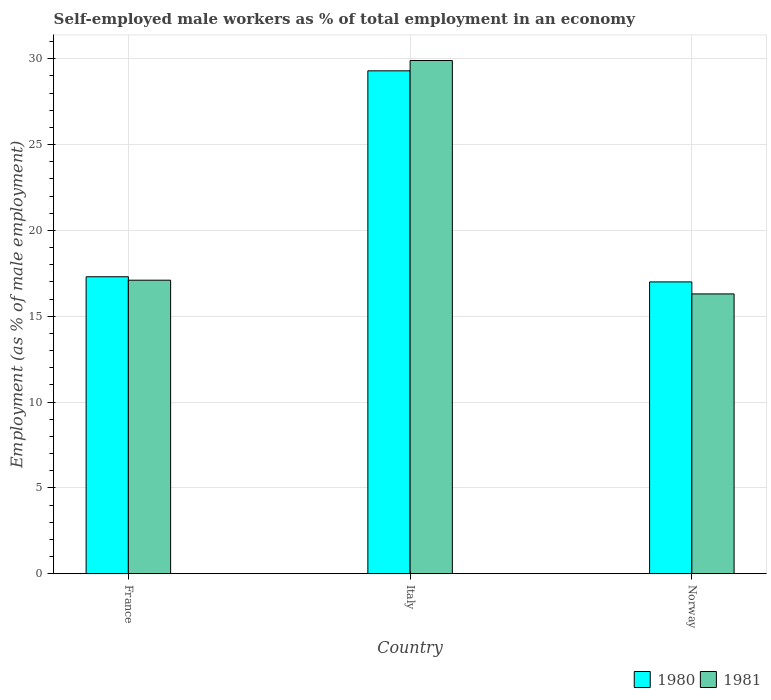How many different coloured bars are there?
Provide a short and direct response. 2. Are the number of bars per tick equal to the number of legend labels?
Your answer should be very brief. Yes. Are the number of bars on each tick of the X-axis equal?
Provide a short and direct response. Yes. How many bars are there on the 1st tick from the left?
Offer a terse response. 2. What is the label of the 3rd group of bars from the left?
Offer a terse response. Norway. In how many cases, is the number of bars for a given country not equal to the number of legend labels?
Give a very brief answer. 0. What is the percentage of self-employed male workers in 1981 in Italy?
Give a very brief answer. 29.9. Across all countries, what is the maximum percentage of self-employed male workers in 1981?
Keep it short and to the point. 29.9. Across all countries, what is the minimum percentage of self-employed male workers in 1981?
Give a very brief answer. 16.3. In which country was the percentage of self-employed male workers in 1981 minimum?
Give a very brief answer. Norway. What is the total percentage of self-employed male workers in 1981 in the graph?
Ensure brevity in your answer.  63.3. What is the difference between the percentage of self-employed male workers in 1981 in France and that in Italy?
Give a very brief answer. -12.8. What is the difference between the percentage of self-employed male workers in 1981 in France and the percentage of self-employed male workers in 1980 in Norway?
Keep it short and to the point. 0.1. What is the average percentage of self-employed male workers in 1980 per country?
Your answer should be compact. 21.2. What is the difference between the percentage of self-employed male workers of/in 1981 and percentage of self-employed male workers of/in 1980 in Italy?
Your answer should be very brief. 0.6. What is the ratio of the percentage of self-employed male workers in 1981 in Italy to that in Norway?
Provide a short and direct response. 1.83. Is the percentage of self-employed male workers in 1980 in France less than that in Norway?
Ensure brevity in your answer.  No. What is the difference between the highest and the second highest percentage of self-employed male workers in 1980?
Ensure brevity in your answer.  -12. What is the difference between the highest and the lowest percentage of self-employed male workers in 1980?
Keep it short and to the point. 12.3. In how many countries, is the percentage of self-employed male workers in 1981 greater than the average percentage of self-employed male workers in 1981 taken over all countries?
Your answer should be very brief. 1. Is the sum of the percentage of self-employed male workers in 1980 in Italy and Norway greater than the maximum percentage of self-employed male workers in 1981 across all countries?
Keep it short and to the point. Yes. What does the 2nd bar from the left in Norway represents?
Offer a very short reply. 1981. What does the 1st bar from the right in Norway represents?
Provide a succinct answer. 1981. How many bars are there?
Provide a succinct answer. 6. Are all the bars in the graph horizontal?
Keep it short and to the point. No. How many countries are there in the graph?
Provide a short and direct response. 3. What is the difference between two consecutive major ticks on the Y-axis?
Provide a short and direct response. 5. Are the values on the major ticks of Y-axis written in scientific E-notation?
Keep it short and to the point. No. Does the graph contain any zero values?
Your answer should be very brief. No. Does the graph contain grids?
Provide a short and direct response. Yes. Where does the legend appear in the graph?
Make the answer very short. Bottom right. What is the title of the graph?
Provide a short and direct response. Self-employed male workers as % of total employment in an economy. What is the label or title of the Y-axis?
Provide a succinct answer. Employment (as % of male employment). What is the Employment (as % of male employment) in 1980 in France?
Your answer should be compact. 17.3. What is the Employment (as % of male employment) in 1981 in France?
Offer a terse response. 17.1. What is the Employment (as % of male employment) of 1980 in Italy?
Ensure brevity in your answer.  29.3. What is the Employment (as % of male employment) of 1981 in Italy?
Offer a terse response. 29.9. What is the Employment (as % of male employment) in 1980 in Norway?
Your response must be concise. 17. What is the Employment (as % of male employment) in 1981 in Norway?
Your answer should be compact. 16.3. Across all countries, what is the maximum Employment (as % of male employment) in 1980?
Offer a terse response. 29.3. Across all countries, what is the maximum Employment (as % of male employment) of 1981?
Offer a very short reply. 29.9. Across all countries, what is the minimum Employment (as % of male employment) of 1981?
Your answer should be compact. 16.3. What is the total Employment (as % of male employment) of 1980 in the graph?
Give a very brief answer. 63.6. What is the total Employment (as % of male employment) in 1981 in the graph?
Offer a terse response. 63.3. What is the difference between the Employment (as % of male employment) in 1980 in France and that in Italy?
Your response must be concise. -12. What is the difference between the Employment (as % of male employment) in 1981 in France and that in Italy?
Provide a succinct answer. -12.8. What is the difference between the Employment (as % of male employment) in 1980 in Italy and the Employment (as % of male employment) in 1981 in Norway?
Ensure brevity in your answer.  13. What is the average Employment (as % of male employment) of 1980 per country?
Ensure brevity in your answer.  21.2. What is the average Employment (as % of male employment) in 1981 per country?
Your response must be concise. 21.1. What is the difference between the Employment (as % of male employment) of 1980 and Employment (as % of male employment) of 1981 in France?
Offer a terse response. 0.2. What is the difference between the Employment (as % of male employment) of 1980 and Employment (as % of male employment) of 1981 in Italy?
Provide a short and direct response. -0.6. What is the ratio of the Employment (as % of male employment) of 1980 in France to that in Italy?
Give a very brief answer. 0.59. What is the ratio of the Employment (as % of male employment) in 1981 in France to that in Italy?
Your answer should be very brief. 0.57. What is the ratio of the Employment (as % of male employment) of 1980 in France to that in Norway?
Your response must be concise. 1.02. What is the ratio of the Employment (as % of male employment) in 1981 in France to that in Norway?
Offer a terse response. 1.05. What is the ratio of the Employment (as % of male employment) of 1980 in Italy to that in Norway?
Keep it short and to the point. 1.72. What is the ratio of the Employment (as % of male employment) in 1981 in Italy to that in Norway?
Offer a terse response. 1.83. What is the difference between the highest and the second highest Employment (as % of male employment) of 1980?
Give a very brief answer. 12. 